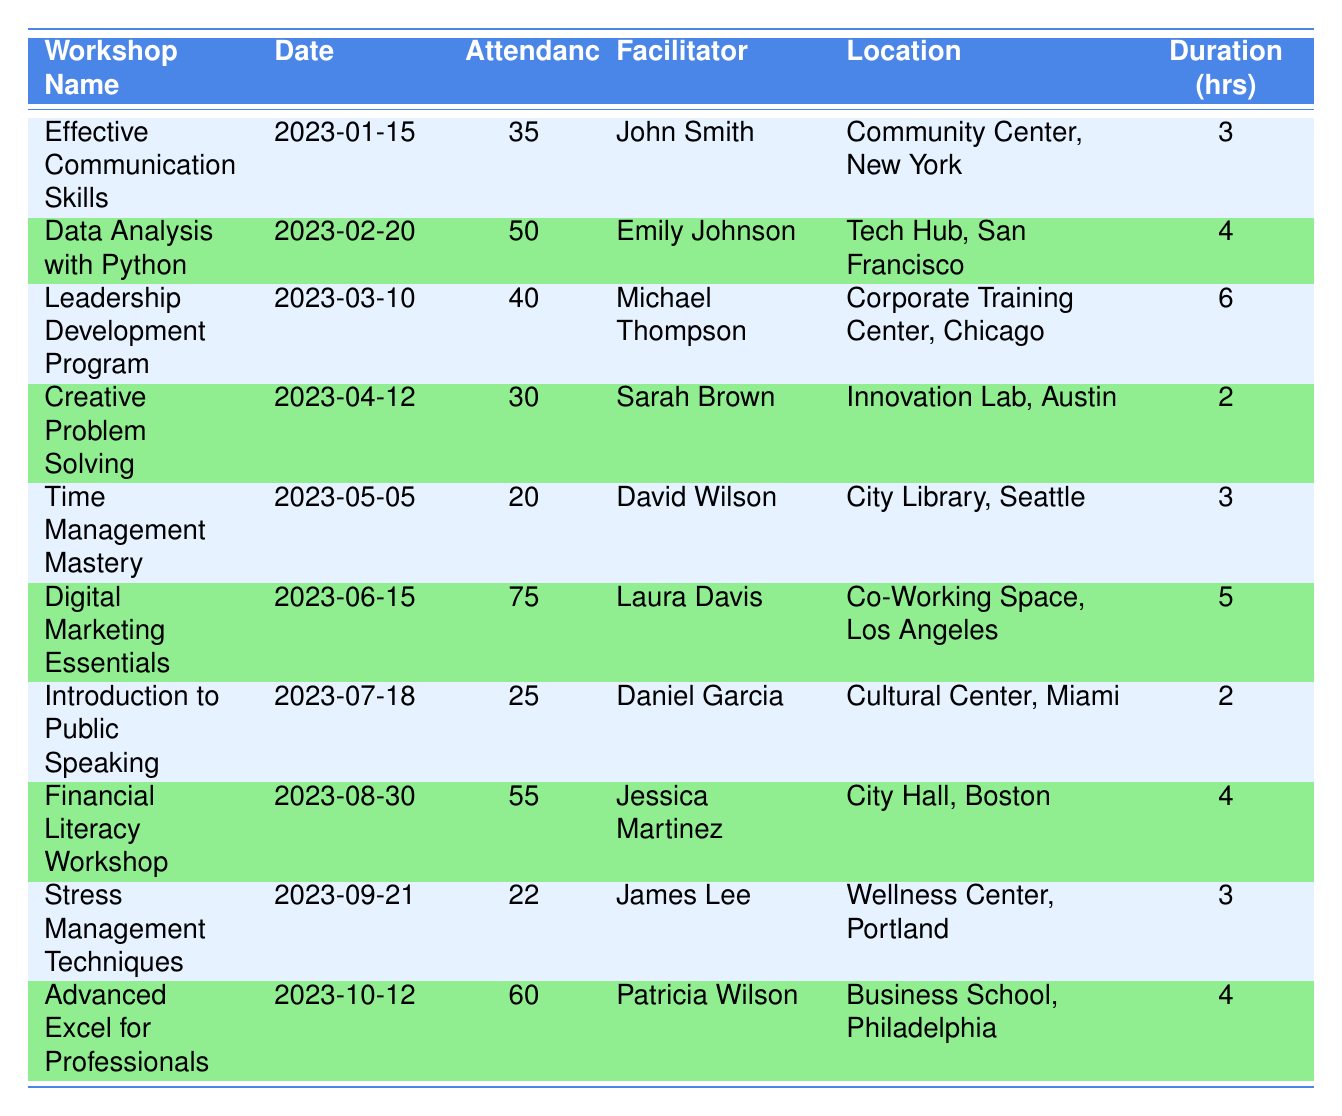What was the attendance for the "Digital Marketing Essentials" workshop? The table directly lists the attendance for each workshop. For "Digital Marketing Essentials," the attendance is found in the corresponding row, which states 75.
Answer: 75 Which workshop had the highest attendance? To find the highest attendance, I scan through the attendance column and identify the maximum value. "Digital Marketing Essentials" has the highest value of 75.
Answer: Digital Marketing Essentials What is the total attendance for all workshops held in the year? I add the attendance values for each workshop: 35 + 50 + 40 + 30 + 20 + 75 + 25 + 55 + 22 + 60 = 412, which gives the total attendance.
Answer: 412 How many workshops had an attendance of more than 50 participants? I review each workshop's attendance and count those that exceed 50. "Data Analysis with Python," "Digital Marketing Essentials," and "Financial Literacy Workshop" are the three that qualify, totaling 3.
Answer: 3 Was the "Stress Management Techniques" workshop attended by more than 20 participants? I check the attendance for "Stress Management Techniques," which is listed as 22. Since 22 is greater than 20, the answer is yes.
Answer: Yes What is the average attendance per workshop? There are 10 workshops, and the total attendance is 412. The average is calculated by dividing the total attendance by the number of workshops: 412 / 10 = 41.2.
Answer: 41.2 Which facilitator conducted the shortest workshop duration and what was that duration? I look at the duration column for the workshop with the shortest time. "Creative Problem Solving" and "Introduction to Public Speaking" each lasted 2 hours, which is the shortest duration. The facilitator for "Creative Problem Solving" is Sarah Brown.
Answer: Sarah Brown, 2 hours Was there more than one workshop held in the first quarter of the year? Looking at the table, there were three workshops before April (January, February, and March). Since there is more than one, the answer is yes.
Answer: Yes What is the difference in attendance between the "Financial Literacy Workshop" and "Time Management Mastery"? I subtract the attendance of "Time Management Mastery" (20) from "Financial Literacy Workshop" (55): 55 - 20 = 35, which gives the difference in attendance.
Answer: 35 